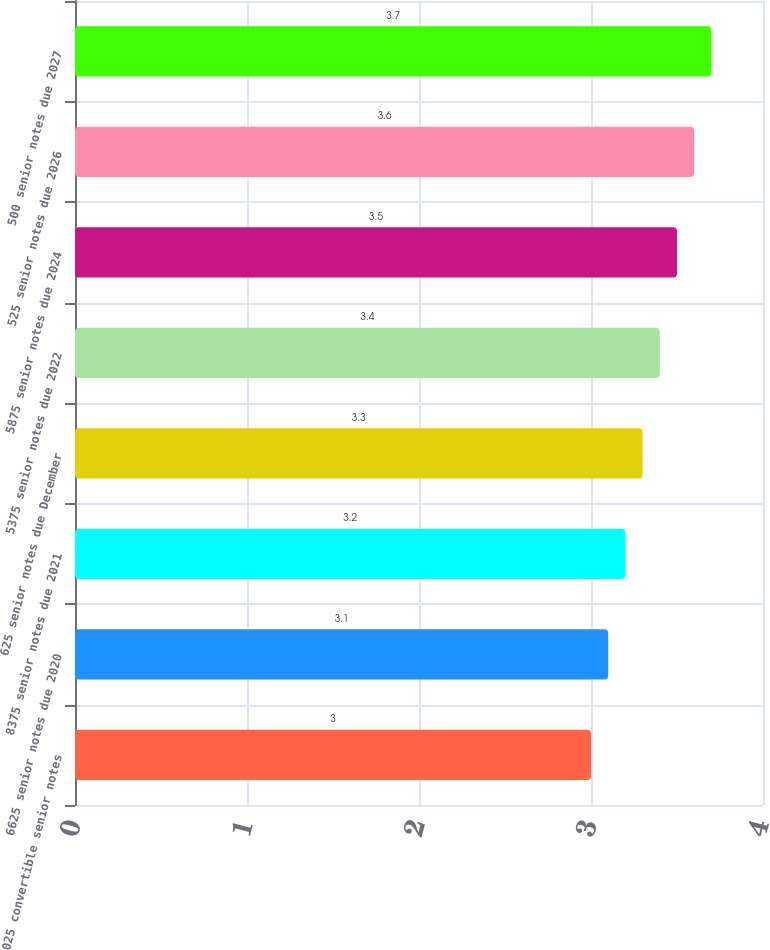<chart> <loc_0><loc_0><loc_500><loc_500><bar_chart><fcel>025 convertible senior notes<fcel>6625 senior notes due 2020<fcel>8375 senior notes due 2021<fcel>625 senior notes due December<fcel>5375 senior notes due 2022<fcel>5875 senior notes due 2024<fcel>525 senior notes due 2026<fcel>500 senior notes due 2027<nl><fcel>3<fcel>3.1<fcel>3.2<fcel>3.3<fcel>3.4<fcel>3.5<fcel>3.6<fcel>3.7<nl></chart> 